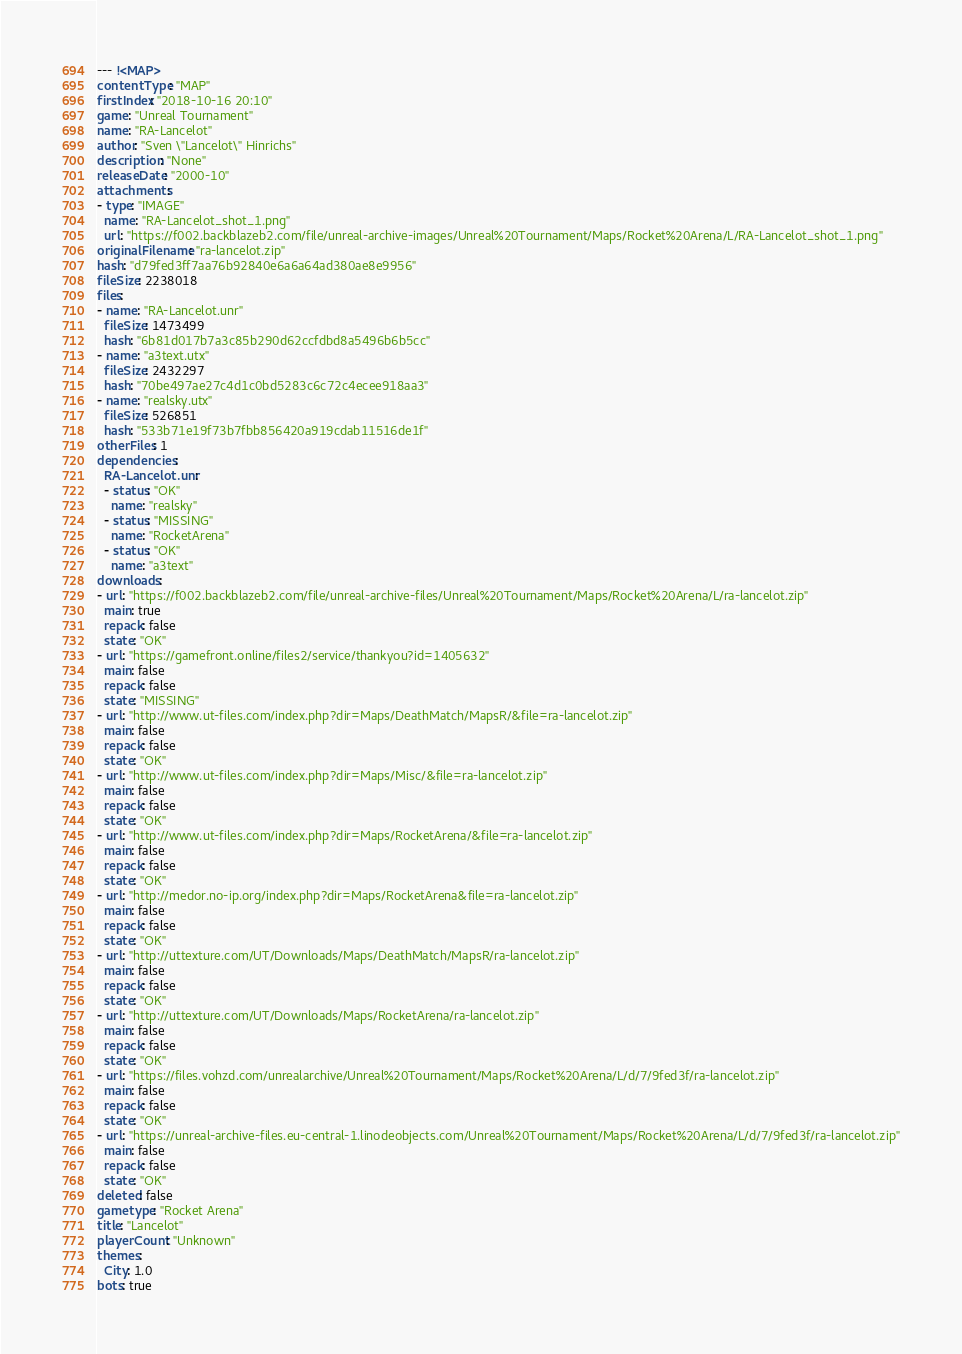<code> <loc_0><loc_0><loc_500><loc_500><_YAML_>--- !<MAP>
contentType: "MAP"
firstIndex: "2018-10-16 20:10"
game: "Unreal Tournament"
name: "RA-Lancelot"
author: "Sven \"Lancelot\" Hinrichs"
description: "None"
releaseDate: "2000-10"
attachments:
- type: "IMAGE"
  name: "RA-Lancelot_shot_1.png"
  url: "https://f002.backblazeb2.com/file/unreal-archive-images/Unreal%20Tournament/Maps/Rocket%20Arena/L/RA-Lancelot_shot_1.png"
originalFilename: "ra-lancelot.zip"
hash: "d79fed3ff7aa76b92840e6a6a64ad380ae8e9956"
fileSize: 2238018
files:
- name: "RA-Lancelot.unr"
  fileSize: 1473499
  hash: "6b81d017b7a3c85b290d62ccfdbd8a5496b6b5cc"
- name: "a3text.utx"
  fileSize: 2432297
  hash: "70be497ae27c4d1c0bd5283c6c72c4ecee918aa3"
- name: "realsky.utx"
  fileSize: 526851
  hash: "533b71e19f73b7fbb856420a919cdab11516de1f"
otherFiles: 1
dependencies:
  RA-Lancelot.unr:
  - status: "OK"
    name: "realsky"
  - status: "MISSING"
    name: "RocketArena"
  - status: "OK"
    name: "a3text"
downloads:
- url: "https://f002.backblazeb2.com/file/unreal-archive-files/Unreal%20Tournament/Maps/Rocket%20Arena/L/ra-lancelot.zip"
  main: true
  repack: false
  state: "OK"
- url: "https://gamefront.online/files2/service/thankyou?id=1405632"
  main: false
  repack: false
  state: "MISSING"
- url: "http://www.ut-files.com/index.php?dir=Maps/DeathMatch/MapsR/&file=ra-lancelot.zip"
  main: false
  repack: false
  state: "OK"
- url: "http://www.ut-files.com/index.php?dir=Maps/Misc/&file=ra-lancelot.zip"
  main: false
  repack: false
  state: "OK"
- url: "http://www.ut-files.com/index.php?dir=Maps/RocketArena/&file=ra-lancelot.zip"
  main: false
  repack: false
  state: "OK"
- url: "http://medor.no-ip.org/index.php?dir=Maps/RocketArena&file=ra-lancelot.zip"
  main: false
  repack: false
  state: "OK"
- url: "http://uttexture.com/UT/Downloads/Maps/DeathMatch/MapsR/ra-lancelot.zip"
  main: false
  repack: false
  state: "OK"
- url: "http://uttexture.com/UT/Downloads/Maps/RocketArena/ra-lancelot.zip"
  main: false
  repack: false
  state: "OK"
- url: "https://files.vohzd.com/unrealarchive/Unreal%20Tournament/Maps/Rocket%20Arena/L/d/7/9fed3f/ra-lancelot.zip"
  main: false
  repack: false
  state: "OK"
- url: "https://unreal-archive-files.eu-central-1.linodeobjects.com/Unreal%20Tournament/Maps/Rocket%20Arena/L/d/7/9fed3f/ra-lancelot.zip"
  main: false
  repack: false
  state: "OK"
deleted: false
gametype: "Rocket Arena"
title: "Lancelot"
playerCount: "Unknown"
themes:
  City: 1.0
bots: true
</code> 